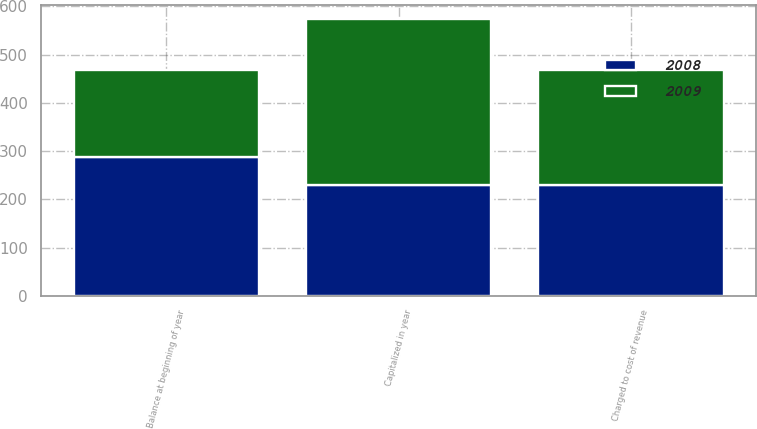Convert chart. <chart><loc_0><loc_0><loc_500><loc_500><stacked_bar_chart><ecel><fcel>Balance at beginning of year<fcel>Capitalized in year<fcel>Charged to cost of revenue<nl><fcel>2008<fcel>287<fcel>230<fcel>229<nl><fcel>2009<fcel>182<fcel>345<fcel>240<nl></chart> 